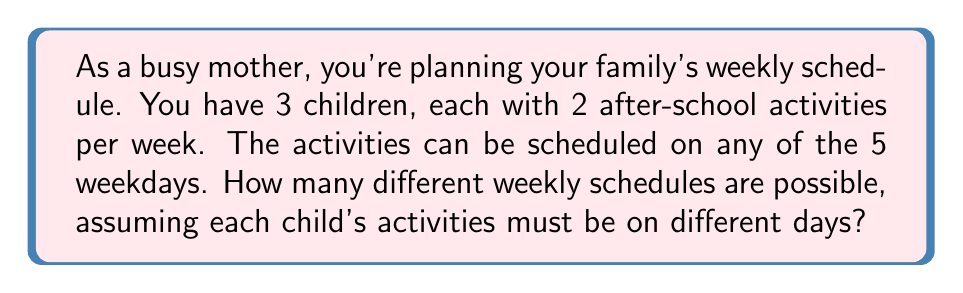What is the answer to this math problem? Let's approach this step-by-step:

1) First, we need to consider each child individually. For each child, we need to choose 2 days out of 5 for their activities.

2) This is a combination problem. The number of ways to choose 2 days out of 5 is denoted as $\binom{5}{2}$ or $C(5,2)$.

3) We can calculate this using the formula:

   $$\binom{5}{2} = \frac{5!}{2!(5-2)!} = \frac{5 \cdot 4}{2 \cdot 1} = 10$$

4) So, for each child, there are 10 possible ways to schedule their activities.

5) Since we have 3 children, and each child's schedule is independent of the others, we multiply these possibilities:

   $$10 \cdot 10 \cdot 10 = 10^3 = 1000$$

Therefore, there are 1000 different possible weekly schedules for the family's activities.
Answer: $1000$ 